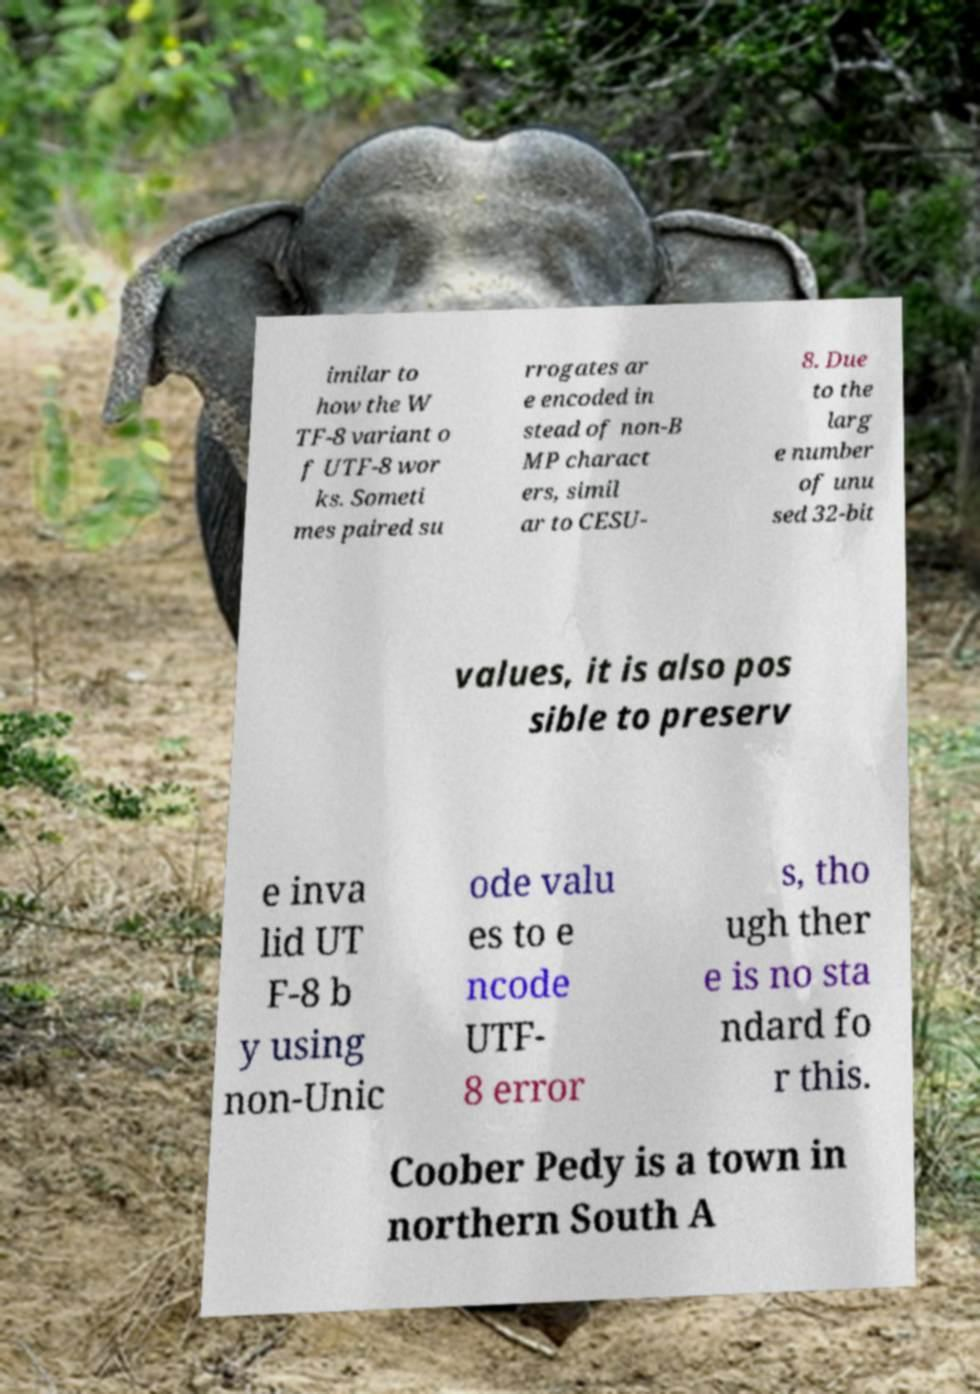For documentation purposes, I need the text within this image transcribed. Could you provide that? imilar to how the W TF-8 variant o f UTF-8 wor ks. Someti mes paired su rrogates ar e encoded in stead of non-B MP charact ers, simil ar to CESU- 8. Due to the larg e number of unu sed 32-bit values, it is also pos sible to preserv e inva lid UT F-8 b y using non-Unic ode valu es to e ncode UTF- 8 error s, tho ugh ther e is no sta ndard fo r this. Coober Pedy is a town in northern South A 